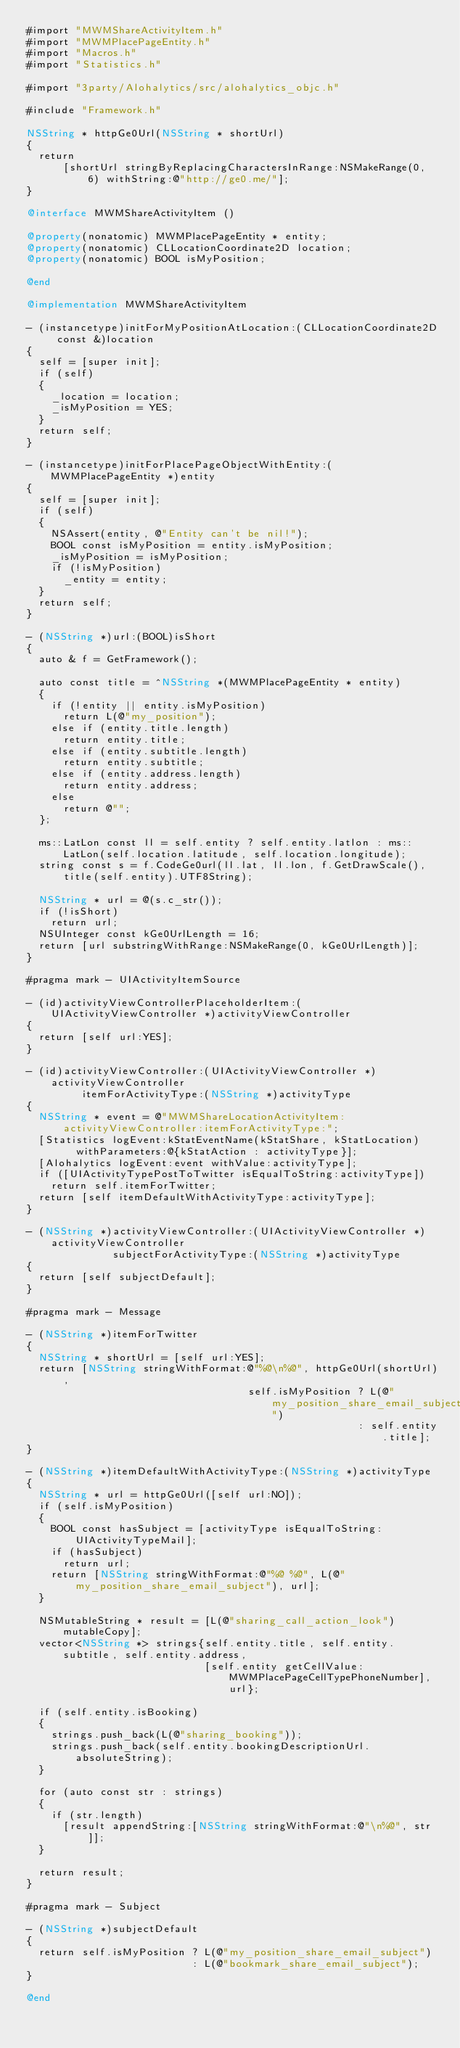<code> <loc_0><loc_0><loc_500><loc_500><_ObjectiveC_>#import "MWMShareActivityItem.h"
#import "MWMPlacePageEntity.h"
#import "Macros.h"
#import "Statistics.h"

#import "3party/Alohalytics/src/alohalytics_objc.h"

#include "Framework.h"

NSString * httpGe0Url(NSString * shortUrl)
{
  return
      [shortUrl stringByReplacingCharactersInRange:NSMakeRange(0, 6) withString:@"http://ge0.me/"];
}

@interface MWMShareActivityItem ()

@property(nonatomic) MWMPlacePageEntity * entity;
@property(nonatomic) CLLocationCoordinate2D location;
@property(nonatomic) BOOL isMyPosition;

@end

@implementation MWMShareActivityItem

- (instancetype)initForMyPositionAtLocation:(CLLocationCoordinate2D const &)location
{
  self = [super init];
  if (self)
  {
    _location = location;
    _isMyPosition = YES;
  }
  return self;
}

- (instancetype)initForPlacePageObjectWithEntity:(MWMPlacePageEntity *)entity
{
  self = [super init];
  if (self)
  {
    NSAssert(entity, @"Entity can't be nil!");
    BOOL const isMyPosition = entity.isMyPosition;
    _isMyPosition = isMyPosition;
    if (!isMyPosition)
      _entity = entity;
  }
  return self;
}

- (NSString *)url:(BOOL)isShort
{
  auto & f = GetFramework();

  auto const title = ^NSString *(MWMPlacePageEntity * entity)
  {
    if (!entity || entity.isMyPosition)
      return L(@"my_position");
    else if (entity.title.length)
      return entity.title;
    else if (entity.subtitle.length)
      return entity.subtitle;
    else if (entity.address.length)
      return entity.address;
    else
      return @"";
  };

  ms::LatLon const ll = self.entity ? self.entity.latlon : ms::LatLon(self.location.latitude, self.location.longitude);
  string const s = f.CodeGe0url(ll.lat, ll.lon, f.GetDrawScale(), title(self.entity).UTF8String);
  
  NSString * url = @(s.c_str());
  if (!isShort)
    return url;
  NSUInteger const kGe0UrlLength = 16;
  return [url substringWithRange:NSMakeRange(0, kGe0UrlLength)];
}

#pragma mark - UIActivityItemSource

- (id)activityViewControllerPlaceholderItem:(UIActivityViewController *)activityViewController
{
  return [self url:YES];
}

- (id)activityViewController:(UIActivityViewController *)activityViewController
         itemForActivityType:(NSString *)activityType
{
  NSString * event = @"MWMShareLocationActivityItem:activityViewController:itemForActivityType:";
  [Statistics logEvent:kStatEventName(kStatShare, kStatLocation)
        withParameters:@{kStatAction : activityType}];
  [Alohalytics logEvent:event withValue:activityType];
  if ([UIActivityTypePostToTwitter isEqualToString:activityType])
    return self.itemForTwitter;
  return [self itemDefaultWithActivityType:activityType];
}

- (NSString *)activityViewController:(UIActivityViewController *)activityViewController
              subjectForActivityType:(NSString *)activityType
{
  return [self subjectDefault];
}

#pragma mark - Message

- (NSString *)itemForTwitter
{
  NSString * shortUrl = [self url:YES];
  return [NSString stringWithFormat:@"%@\n%@", httpGe0Url(shortUrl),
                                    self.isMyPosition ? L(@"my_position_share_email_subject")
                                                      : self.entity.title];
}

- (NSString *)itemDefaultWithActivityType:(NSString *)activityType
{
  NSString * url = httpGe0Url([self url:NO]);
  if (self.isMyPosition)
  {
    BOOL const hasSubject = [activityType isEqualToString:UIActivityTypeMail];
    if (hasSubject)
      return url;
    return [NSString stringWithFormat:@"%@ %@", L(@"my_position_share_email_subject"), url];
  }

  NSMutableString * result = [L(@"sharing_call_action_look") mutableCopy];
  vector<NSString *> strings{self.entity.title, self.entity.subtitle, self.entity.address,
                             [self.entity getCellValue:MWMPlacePageCellTypePhoneNumber], url};

  if (self.entity.isBooking)
  {
    strings.push_back(L(@"sharing_booking"));
    strings.push_back(self.entity.bookingDescriptionUrl.absoluteString);
  }

  for (auto const str : strings)
  {
    if (str.length)
      [result appendString:[NSString stringWithFormat:@"\n%@", str]];
  }

  return result;
}

#pragma mark - Subject

- (NSString *)subjectDefault
{
  return self.isMyPosition ? L(@"my_position_share_email_subject")
                           : L(@"bookmark_share_email_subject");
}

@end
</code> 